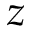Convert formula to latex. <formula><loc_0><loc_0><loc_500><loc_500>z</formula> 